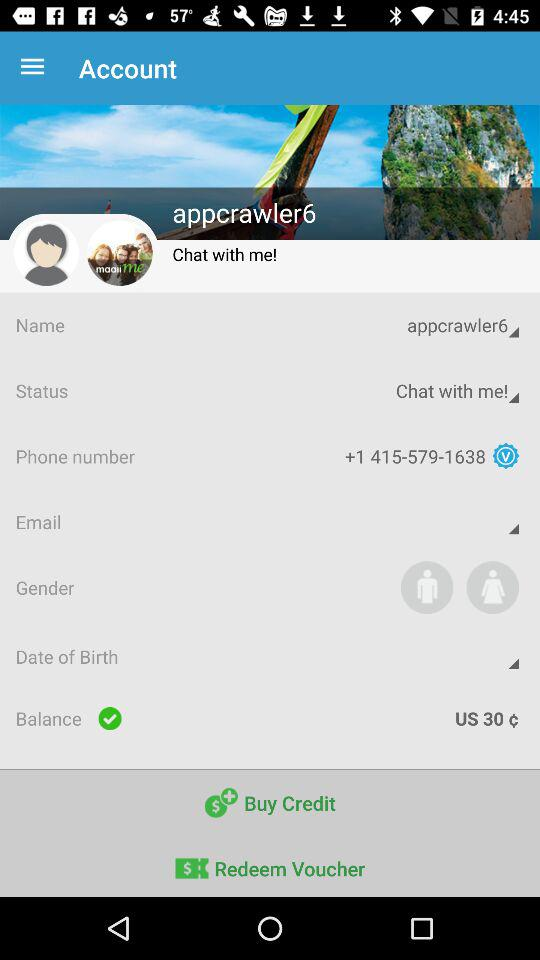What is the balance amount? The balance amount is 30 U.S. cents. 